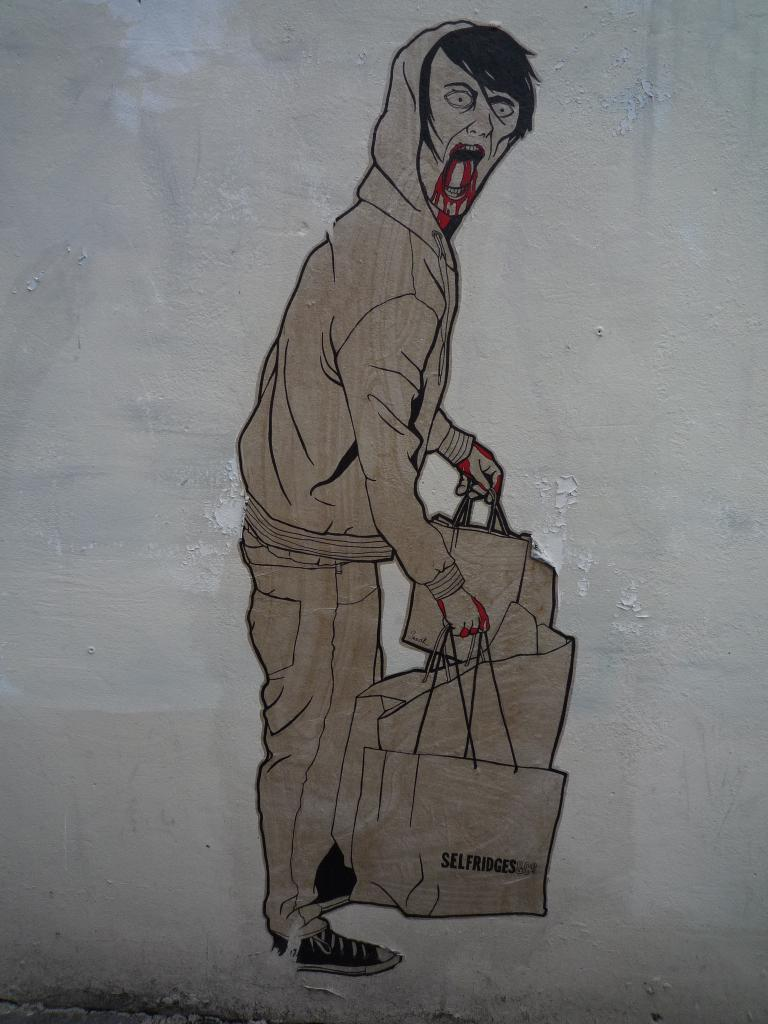What is depicted in the painting in the image? There is a painting of a person in the image. What is the person in the painting wearing? The person in the painting is in a zombie costume. What is the person in the painting holding? The person in the painting is holding bags in their hands. What theory is the person in the painting trying to prove? There is no indication in the image that the person in the painting is trying to prove any theory. 